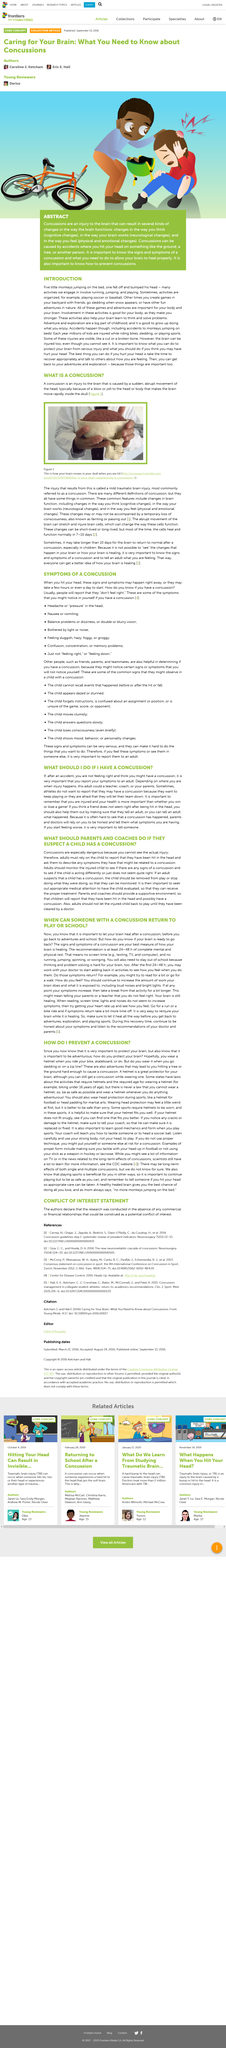Outline some significant characteristics in this image. A concussion is not a visual injury, and it cannot be seen with the naked eye. Cognitive changes refer to changes in the way one thinks, perceives, and processes information. It is important for adults to rely on a child's self-reporting of an injury in order to determine if the child has a concussion. In the Abstract article, the bike is depicted as being orange. Coaches and parents should provide a supportive environment for children to report possible concussions in order to ensure that they receive appropriate medical attention and prevent further harm to their health. 